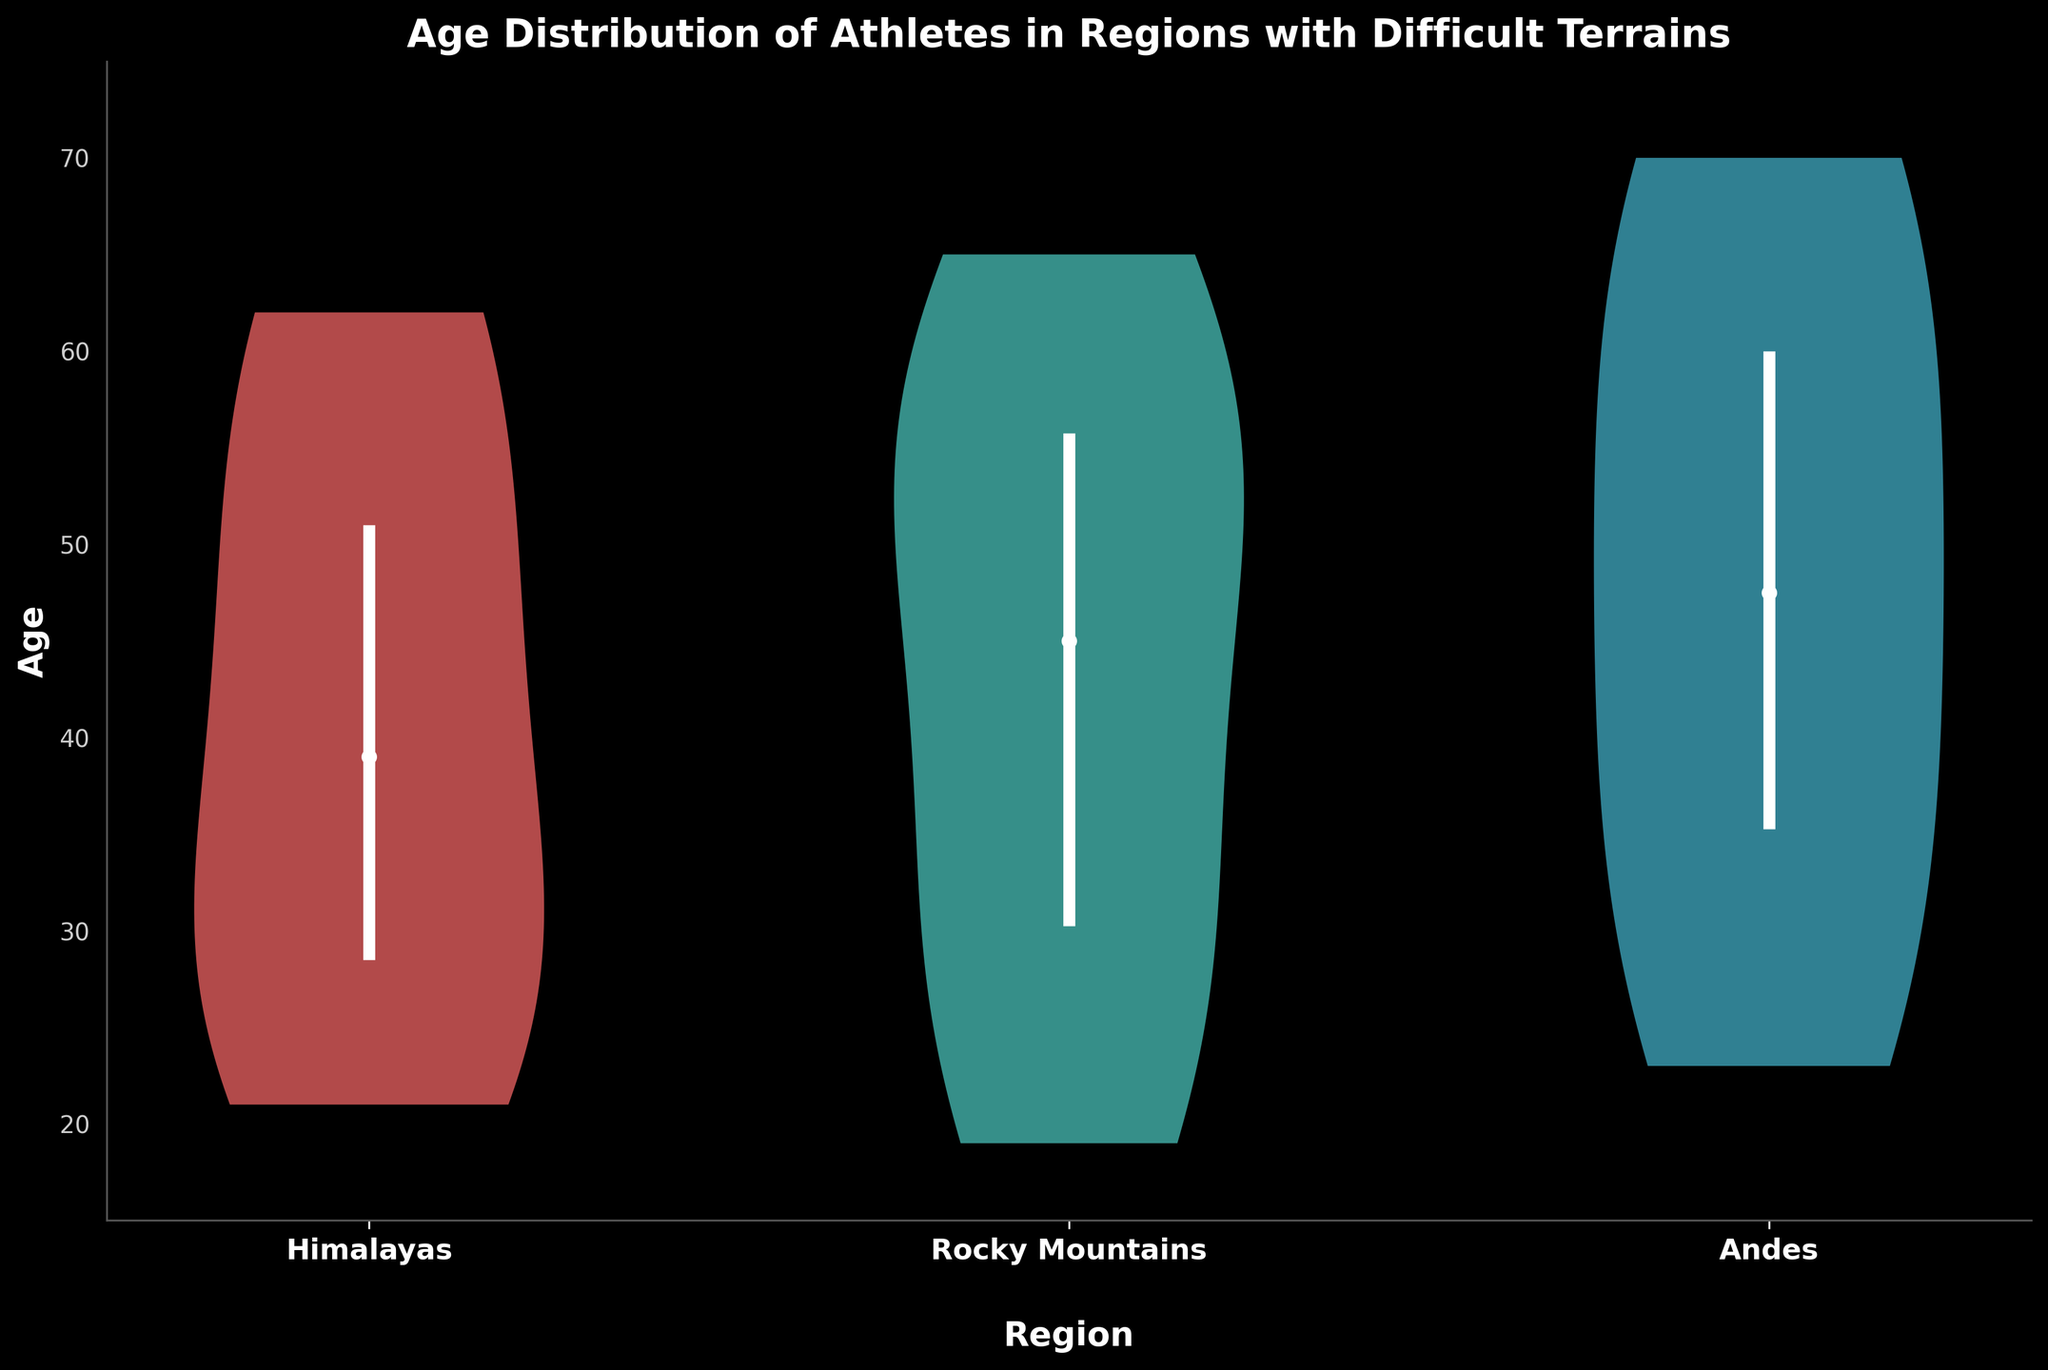What is the title of the plot? The title of the plot is the text presented at the top center of the plot, which provides a brief description of the visualized data. In this case, the title is "Age Distribution of Athletes in Regions with Difficult Terrains".
Answer: Age Distribution of Athletes in Regions with Difficult Terrains What are the regions compared in the plot? The regions compared in the plot are indicated on the x-axis. Each tick mark on the x-axis represents one region. The regions in this analysis are "Himalayas," "Rocky Mountains," and "Andes".
Answer: Himalayas, Rocky Mountains, Andes Which region has the youngest median age of athletes? To determine which region has the youngest median age, observe the white dots representing the median in each violin plot. The region with the lowest position of the white dot corresponds to the youngest median age. The "Rocky Mountains" region has the lowest median age.
Answer: Rocky Mountains How does the age range (25th to 75th percentile) in the Andes compare to the other regions? The age range is represented by the lines between the 25th and 75th percentiles in each violin plot. By comparing these lines, it can be seen that the Andes region has a slightly wider interquartile range (IQR) than the Himalayas and Rocky Mountains.
Answer: The Andes have a wider age range What is the age range for the "Himalayas" region? The age range can be found by looking at the positions of the top and bottom of the violin plot. For the "Himalayas" region, the ages range approximately from around 21 to 62.
Answer: 21 to 62 In which region do athletes have the largest age variability? Age variability can be inferred from the width and spread of each violin plot. A wider and more spread-out plot suggests more variability. The "Andes" region displays the widest and most spread distribution, indicating the largest age variability.
Answer: Andes Comparing the median age of athletes, rank the regions from youngest to oldest. Look at the position of the median (white dot) in each violin plot and rank them from the lowest to the highest. The order is "Rocky Mountains," followed by "Andes," and then "Himalayas".
Answer: Rocky Mountains, Andes, Himalayas What is the typical age distribution pattern you observe in the violin chart? Violin plots illustrate the distribution pattern. Typically, the density is higher around certain ages showing where the majority lies. In this chart, the Andes and Himalayas show a broader distribution, while the Rocky Mountains have a visible concentration around younger ages.
Answer: Broader in Andes & Himalayas; concentrated in Rocky Mountains 